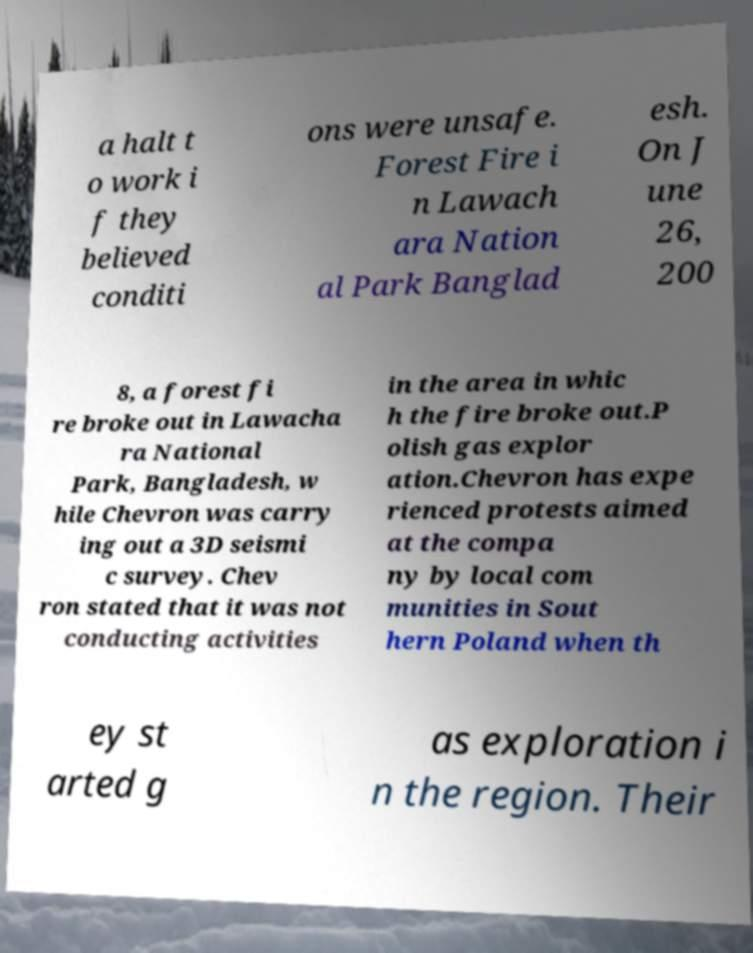Could you assist in decoding the text presented in this image and type it out clearly? a halt t o work i f they believed conditi ons were unsafe. Forest Fire i n Lawach ara Nation al Park Banglad esh. On J une 26, 200 8, a forest fi re broke out in Lawacha ra National Park, Bangladesh, w hile Chevron was carry ing out a 3D seismi c survey. Chev ron stated that it was not conducting activities in the area in whic h the fire broke out.P olish gas explor ation.Chevron has expe rienced protests aimed at the compa ny by local com munities in Sout hern Poland when th ey st arted g as exploration i n the region. Their 